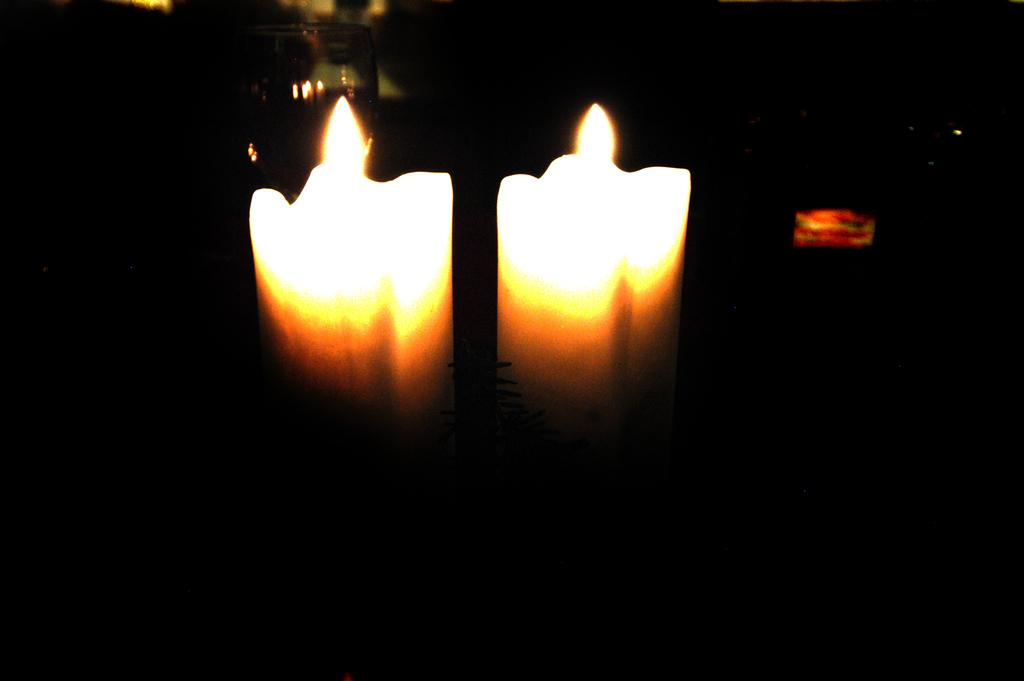How many candles are visible in the image? There are two candles in the image. Can you describe the lighting conditions in the image? The image is unclear and dark. What songs are being sung by the people in the image? There are no people or singing in the image; it only features two candles. 